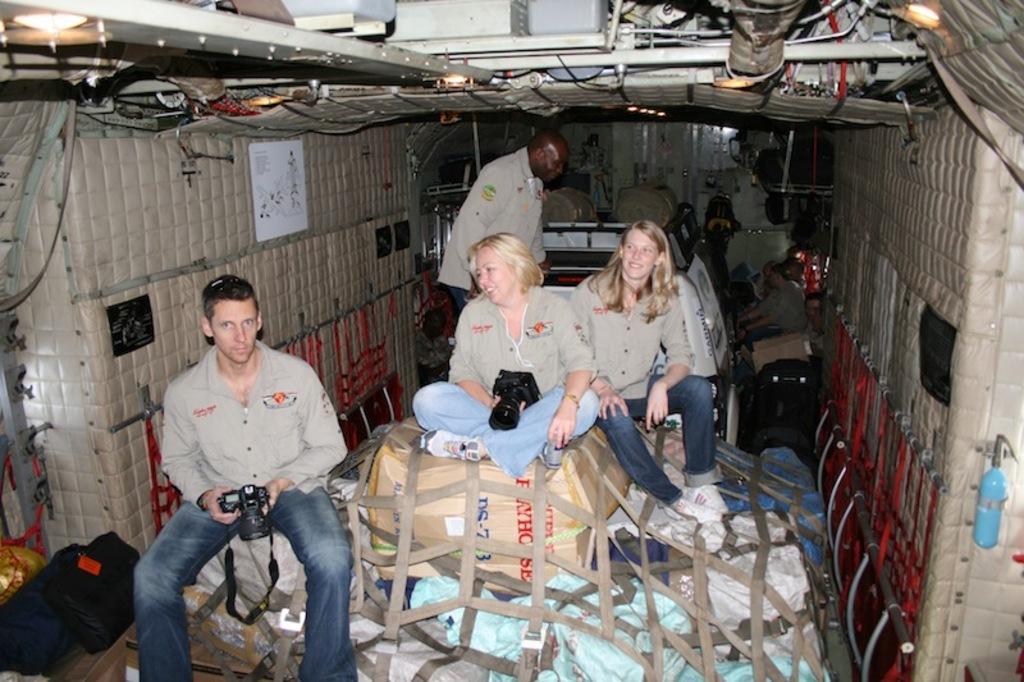In one or two sentences, can you explain what this image depicts? In this image we can see some people, carton box, cameras, ropes and we can also see the lights. 